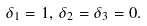<formula> <loc_0><loc_0><loc_500><loc_500>\delta _ { 1 } = 1 , \, \delta _ { 2 } = \delta _ { 3 } = 0 .</formula> 